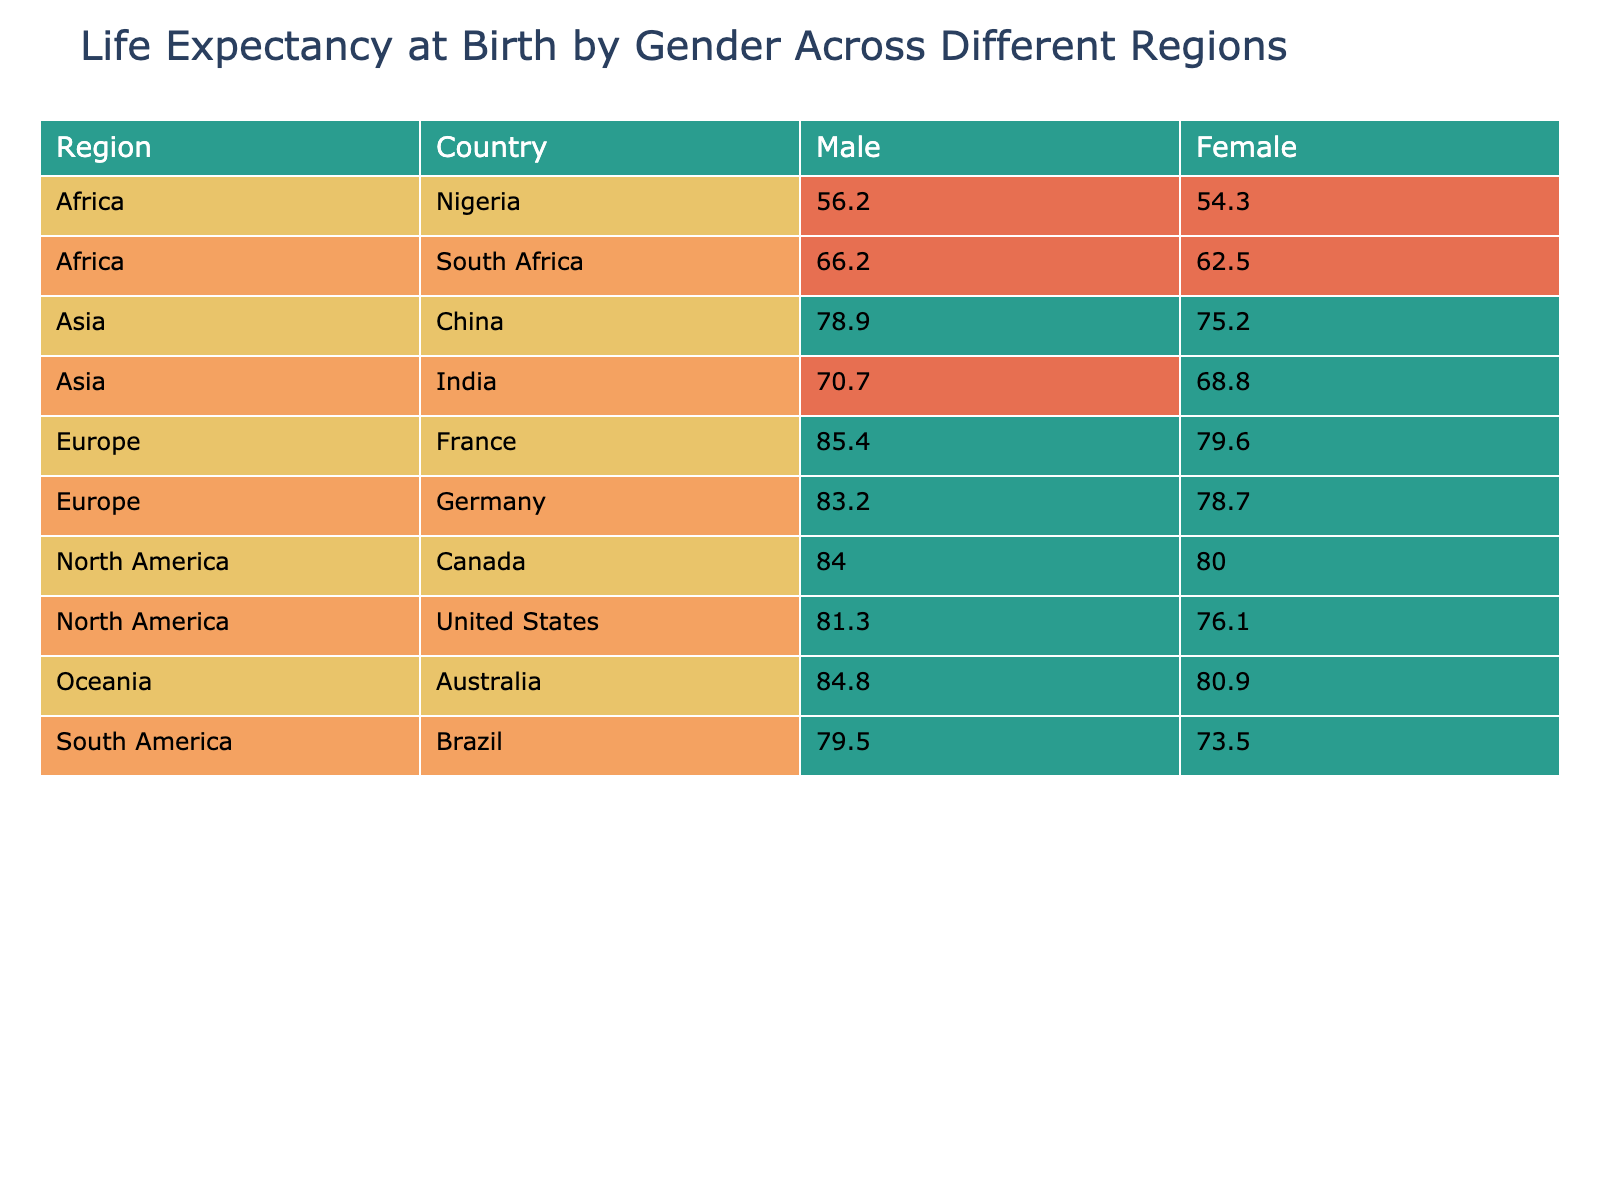What is the life expectancy at birth for females in Canada? The table shows that in Canada, the life expectancy at birth for females is listed as 84.0 years.
Answer: 84.0 years Which country has the lowest life expectancy at birth for males in Africa? In Africa, Nigeria has the lowest life expectancy at birth for males, which is 54.3 years, according to the table.
Answer: 54.3 years What is the difference in life expectancy at birth between males and females in Germany? In Germany, the life expectancy for males is 78.7 years, and for females, it is 83.2 years. The difference is calculated as 83.2 - 78.7 = 4.5 years.
Answer: 4.5 years Is the life expectancy at birth for males in South Africa below 70 years? The table indicates that the life expectancy for males in South Africa is 62.5 years, which is indeed below 70 years.
Answer: Yes What is the average life expectancy at birth for males across all countries listed? To find the average for males, add the values: (76.1 + 80.0 + 78.7 + 79.6 + 75.2 + 68.8 + 54.3 + 62.5 + 80.9 + 73.5) = 779.6. There are 10 data points, so the average is 779.6/10 = 77.96 years.
Answer: 77.96 years Which region has the highest life expectancy at birth for females? Among the listed regions, France has the highest female life expectancy at birth at 85.4 years, according to the table.
Answer: 85.4 years How many countries have a life expectancy at birth greater than 80 years for females? By checking the table, the countries with female life expectancy over 80 years are the United States, Canada, Germany, France, Australia, and Brazil. This totals to 5 countries.
Answer: 5 countries Which region has the lowest average life expectancy at birth for males? To determine the region with the lowest average for males, we can summarize: North America averages (76.1 + 80.0)/2 = 78.05; Europe (78.7 + 79.6)/2 = 79.15; Asia (75.2 + 68.8)/2 = 72.0; Africa (54.3 + 62.5)/2 = 58.4; Oceania (80.9)/1 = 80.9; South America (73.5)/1 = 73.5. Africa has the lowest average at 58.4 years.
Answer: Africa 